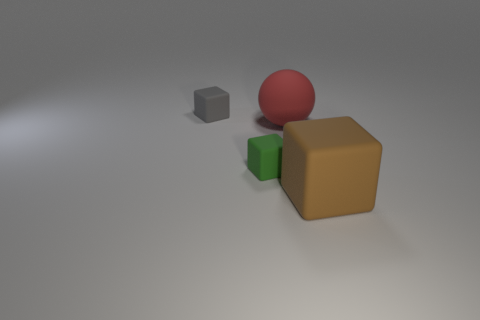Is the number of brown rubber objects less than the number of tiny rubber objects?
Make the answer very short. Yes. There is a rubber object on the right side of the ball; does it have the same shape as the green matte thing?
Your answer should be compact. Yes. Is there a large red ball?
Ensure brevity in your answer.  Yes. What color is the tiny cube behind the small block in front of the small block behind the red ball?
Provide a succinct answer. Gray. Are there an equal number of large blocks that are behind the large brown thing and brown objects to the left of the gray rubber thing?
Provide a short and direct response. Yes. What is the shape of the matte object that is the same size as the red ball?
Offer a very short reply. Cube. Are there any rubber cubes of the same color as the sphere?
Provide a short and direct response. No. What shape is the big object behind the large cube?
Provide a short and direct response. Sphere. The big rubber ball has what color?
Your answer should be very brief. Red. There is a big sphere that is the same material as the tiny gray block; what color is it?
Offer a terse response. Red. 